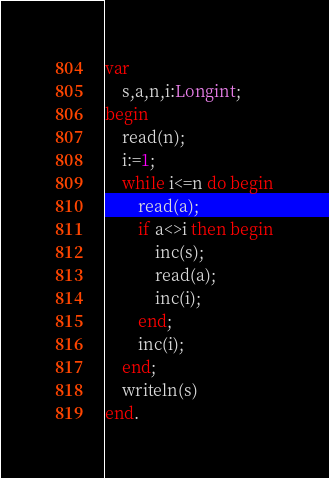Convert code to text. <code><loc_0><loc_0><loc_500><loc_500><_Pascal_>var
	s,a,n,i:Longint;
begin
	read(n);
	i:=1;
	while i<=n do begin
		read(a);
		if a<>i then begin
			inc(s);
			read(a);
			inc(i);
		end;
		inc(i);
	end;
	writeln(s)
end.
</code> 